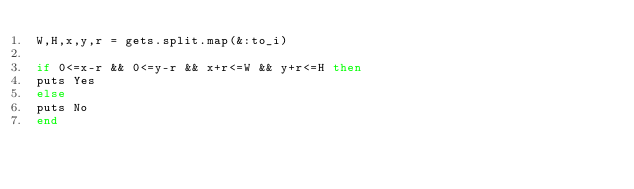Convert code to text. <code><loc_0><loc_0><loc_500><loc_500><_Ruby_>W,H,x,y,r = gets.split.map(&:to_i)
 
if 0<=x-r && 0<=y-r && x+r<=W && y+r<=H then
puts Yes
else
puts No
end</code> 